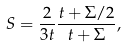Convert formula to latex. <formula><loc_0><loc_0><loc_500><loc_500>S = \frac { 2 } { 3 t } \frac { t + \Sigma / 2 } { t + \Sigma } ,</formula> 